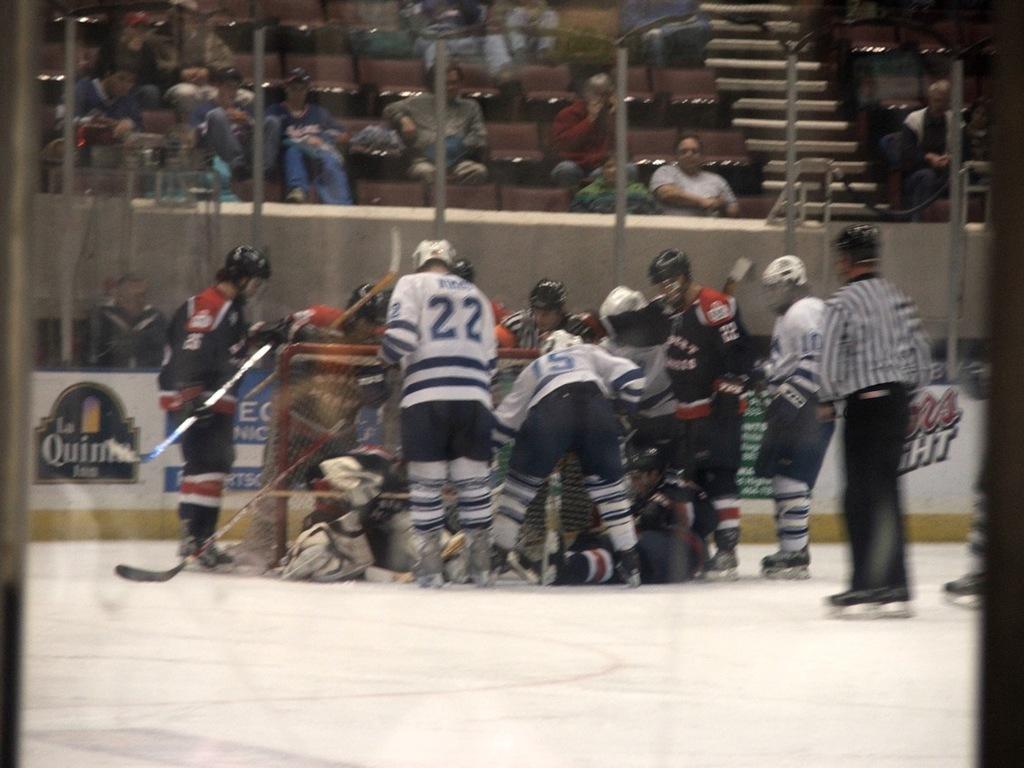Can you describe this image briefly? In this picture we can see some hockey players in the front. Behind there are some audience sitting and watching the game. 